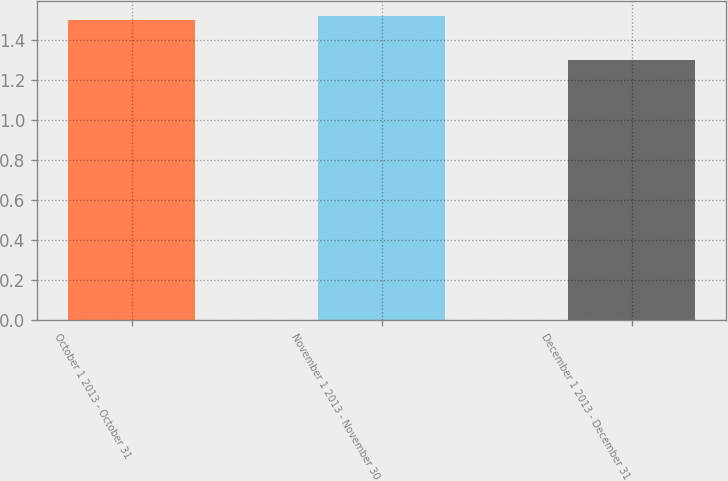<chart> <loc_0><loc_0><loc_500><loc_500><bar_chart><fcel>October 1 2013 - October 31<fcel>November 1 2013 - November 30<fcel>December 1 2013 - December 31<nl><fcel>1.5<fcel>1.52<fcel>1.3<nl></chart> 